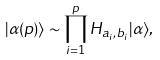Convert formula to latex. <formula><loc_0><loc_0><loc_500><loc_500>| \alpha ( p ) \rangle \sim \prod _ { i = 1 } ^ { p } H _ { a _ { i } , b _ { i } } | \alpha \rangle ,</formula> 